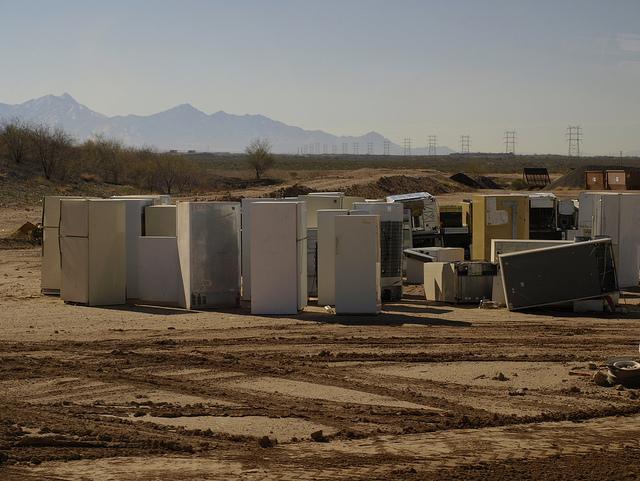How many refrigerators are there?
Give a very brief answer. 10. How many people are wearing glasses?
Give a very brief answer. 0. 